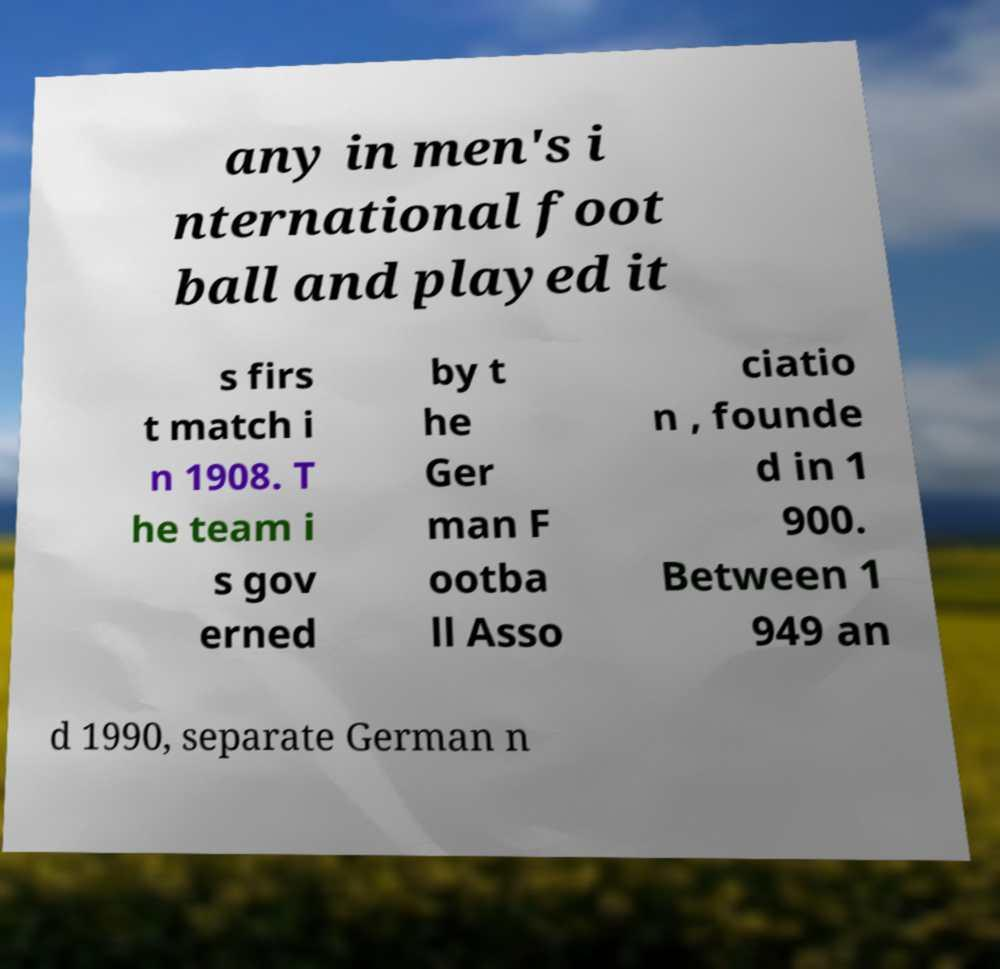For documentation purposes, I need the text within this image transcribed. Could you provide that? any in men's i nternational foot ball and played it s firs t match i n 1908. T he team i s gov erned by t he Ger man F ootba ll Asso ciatio n , founde d in 1 900. Between 1 949 an d 1990, separate German n 